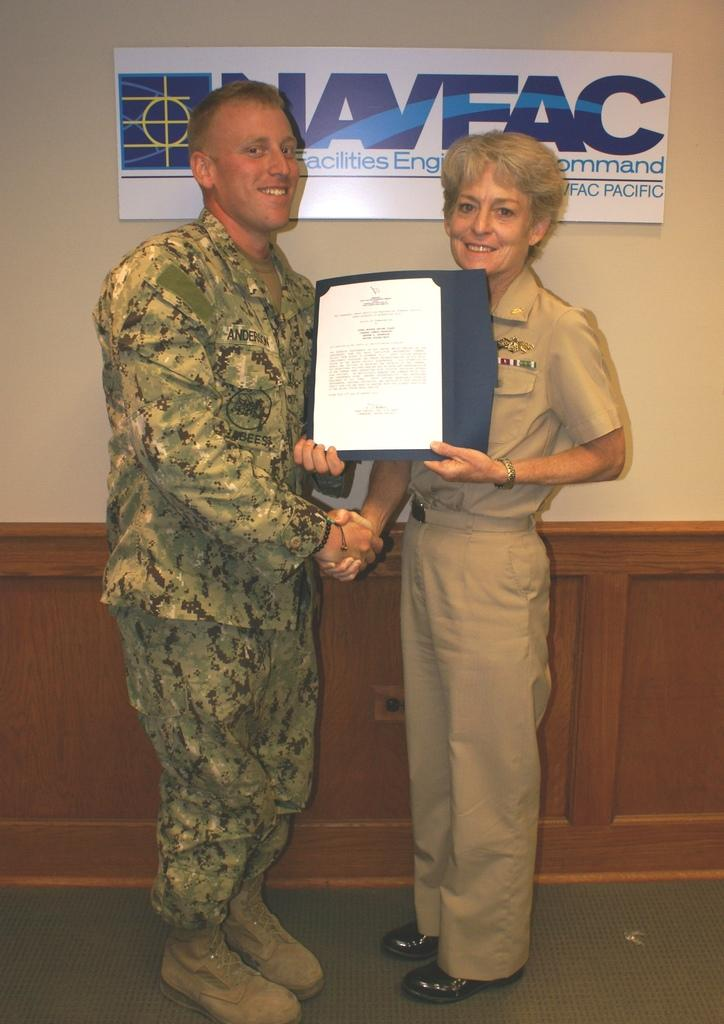<image>
Render a clear and concise summary of the photo. a man in an army uniform poses in front of a sign with the letters AC at the end 